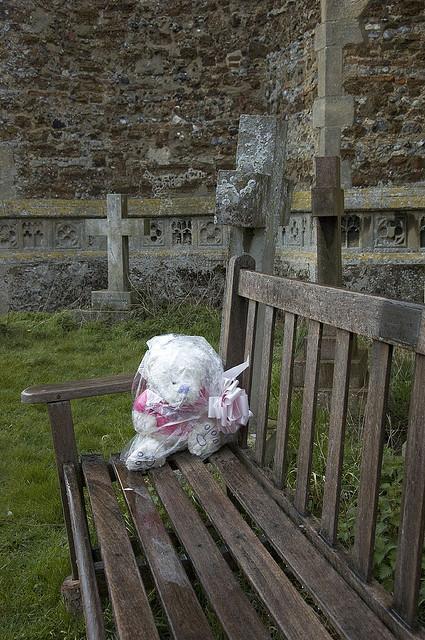How many people in this image are wearing hats?
Give a very brief answer. 0. 